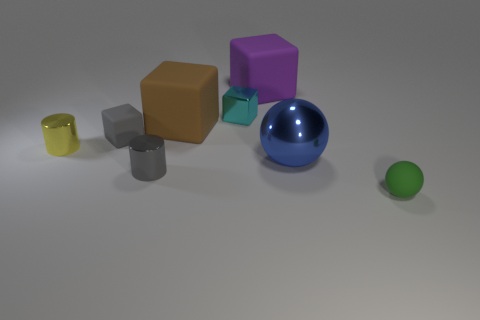The big matte cube that is in front of the tiny cyan shiny cube is what color?
Your response must be concise. Brown. What number of green balls are in front of the big matte thing that is on the left side of the purple object?
Provide a short and direct response. 1. Do the green rubber sphere and the rubber block to the right of the large brown rubber object have the same size?
Provide a succinct answer. No. Is there a yellow ball that has the same size as the blue thing?
Offer a terse response. No. How many objects are either metal cubes or matte cubes?
Provide a short and direct response. 4. There is a metal thing right of the large purple rubber object; does it have the same size as the rubber thing that is right of the large purple rubber thing?
Provide a succinct answer. No. Is there a large purple object of the same shape as the cyan thing?
Offer a very short reply. Yes. Is the number of brown things in front of the large ball less than the number of tiny shiny cylinders?
Keep it short and to the point. Yes. Do the yellow thing and the big blue thing have the same shape?
Your response must be concise. No. What size is the sphere that is left of the tiny green matte sphere?
Your response must be concise. Large. 